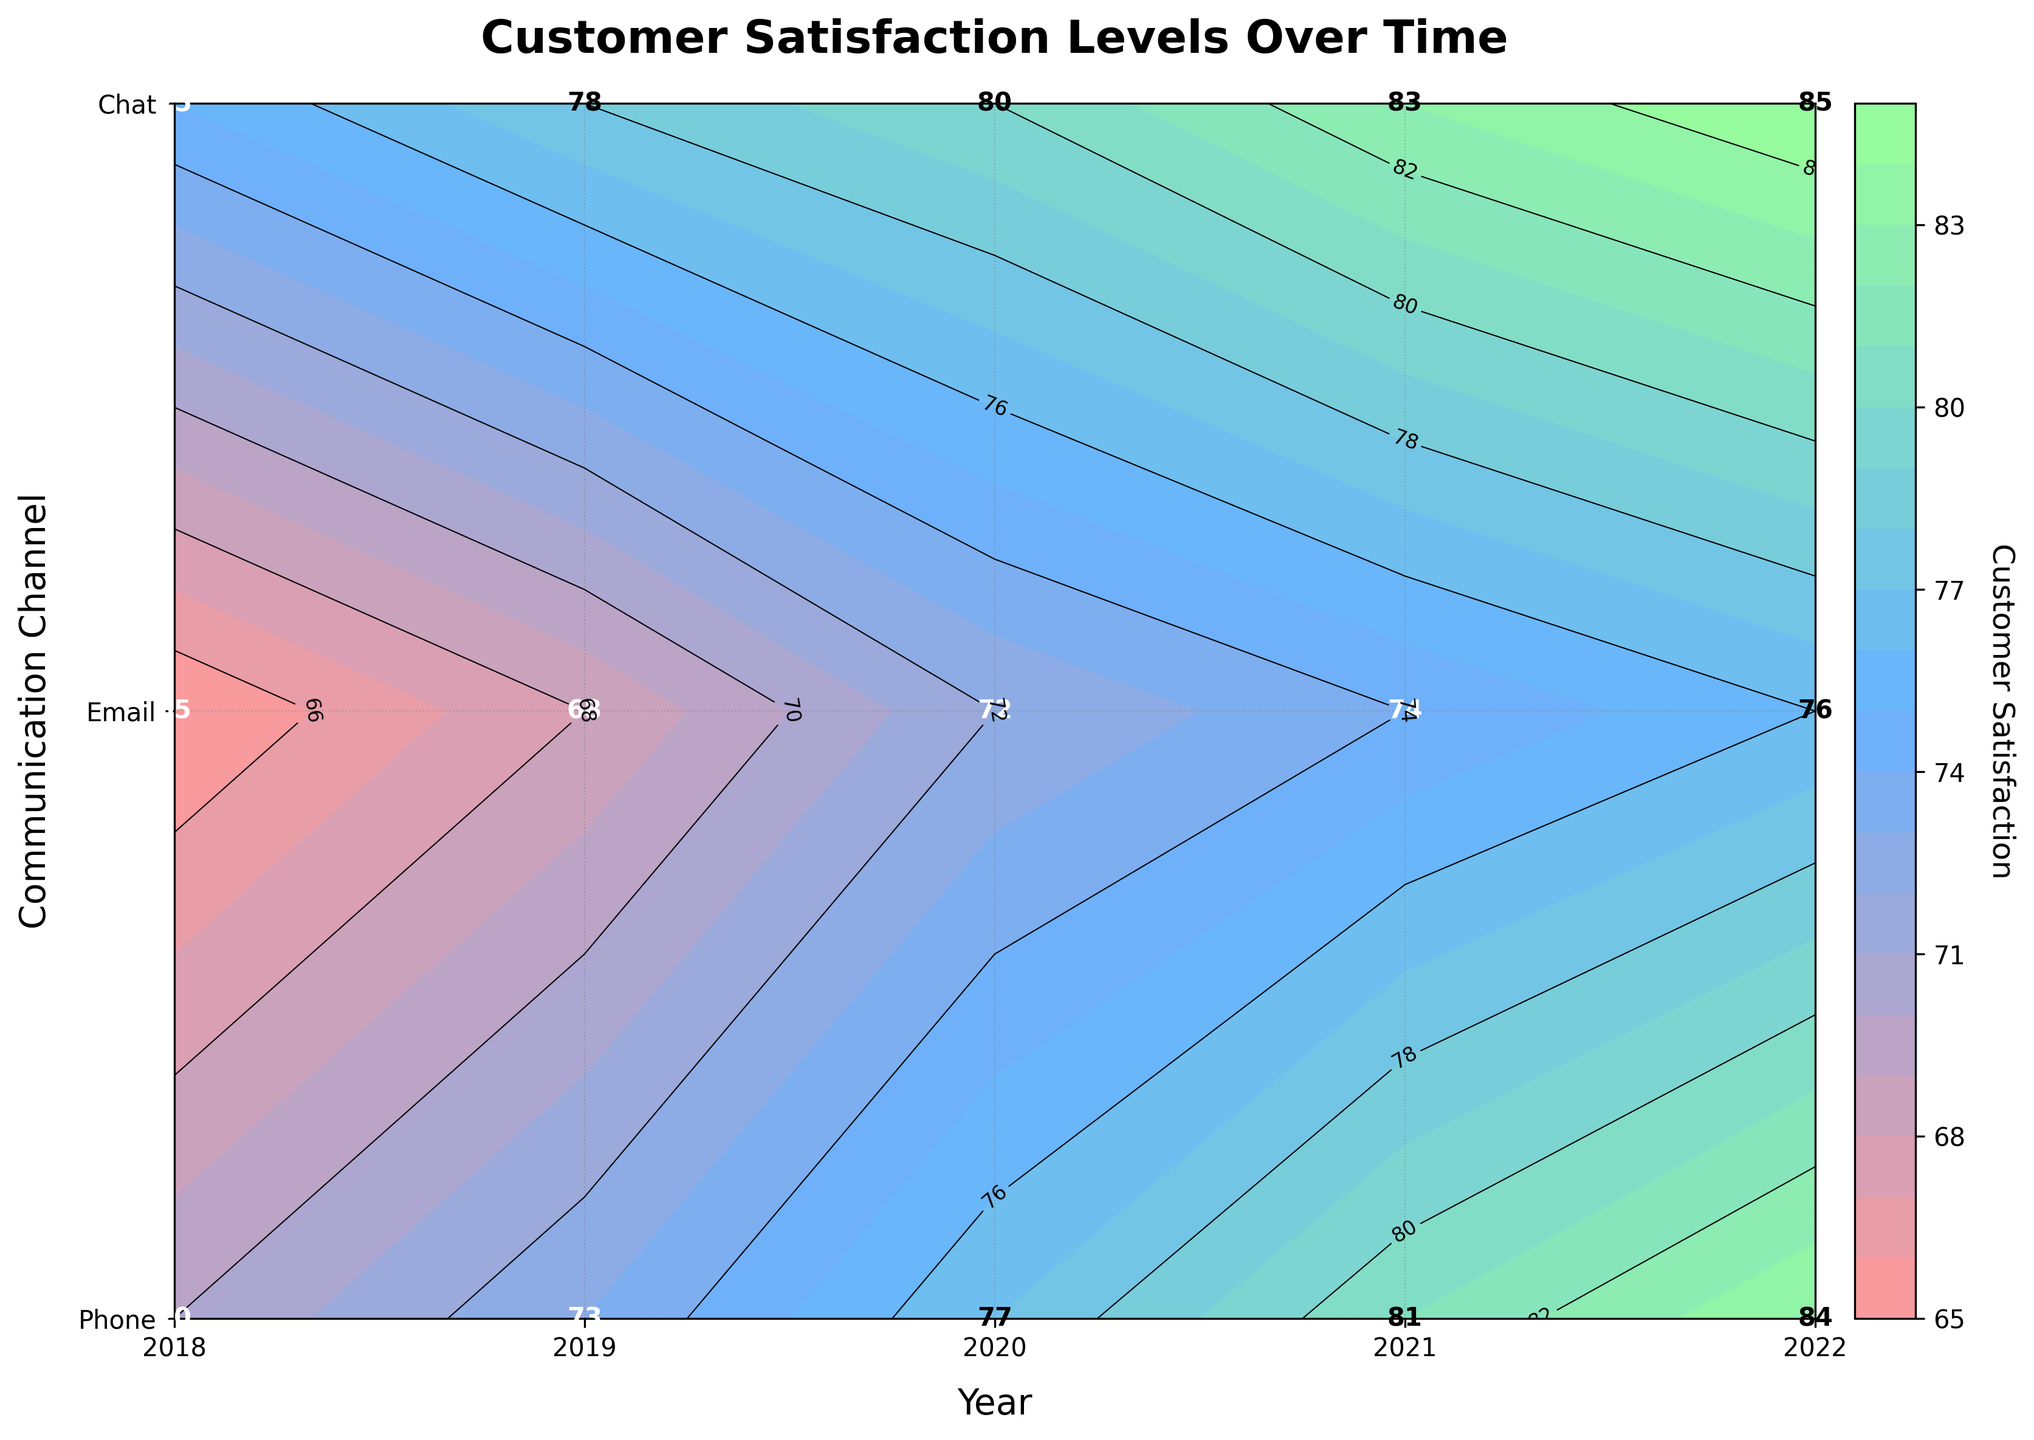What's the title of the plot? The title is located at the top of the plot. It summarizes the main point of the figure. The title given is "Customer Satisfaction Levels Over Time".
Answer: Customer Satisfaction Levels Over Time What is the customer satisfaction level for Chat in 2020? Locate the year 2020 on the x-axis and the Chat channel on the y-axis. The contour plot marks this position with a value label, which shows the customer satisfaction level.
Answer: 77 Which communication channel had the highest customer satisfaction in 2022? Look along the 2022 line on the x-axis at the value labels for the different communication channels. The highest number on this line indicates the highest customer satisfaction.
Answer: Phone By how much did the customer satisfaction for Email increase from 2018 to 2022? Find the customer satisfaction values for Email in both 2018 and 2022. Subtract the 2018 value from the 2022 value to determine the increase.
Answer: 11 Compare the customer satisfaction levels between Phone and Chat in 2021. Which channel was higher? Identify the customer satisfaction levels for both Phone and Chat in 2021. Compare these values to see which is higher.
Answer: Phone On average, how did customer satisfaction change each year for the Phone channel from 2018 to 2022? List all customer satisfaction values for Phone from 2018 to 2022. Calculate the total increase over the years and divide by the number of years (4) to find the average annual change.
Answer: 2.5 Is there a trend observable in the customer satisfaction levels for Chat over the years? Examine the customer satisfaction values for Chat from 2018 to 2022. An increasing or decreasing pattern indicates a trend.
Answer: Increasing Which year shows the most significant increase in customer satisfaction for Email compared to the previous year? Calculate the difference in customer satisfaction between consecutive years for Email. Identify the year with the largest positive difference.
Answer: 2020 Describe the color range representing customer satisfaction in the plot. The contour plot uses a color gradient to represent different customer satisfaction levels. Check the plot legend for the color range.
Answer: Red to Green What is the customer satisfaction for Phone and Email in 2020 and compare them? Locate the 2020 satisfaction values for both Phone and Email. Compare these two numbers to determine which is higher.
Answer: Phone: 80, Email: 72 